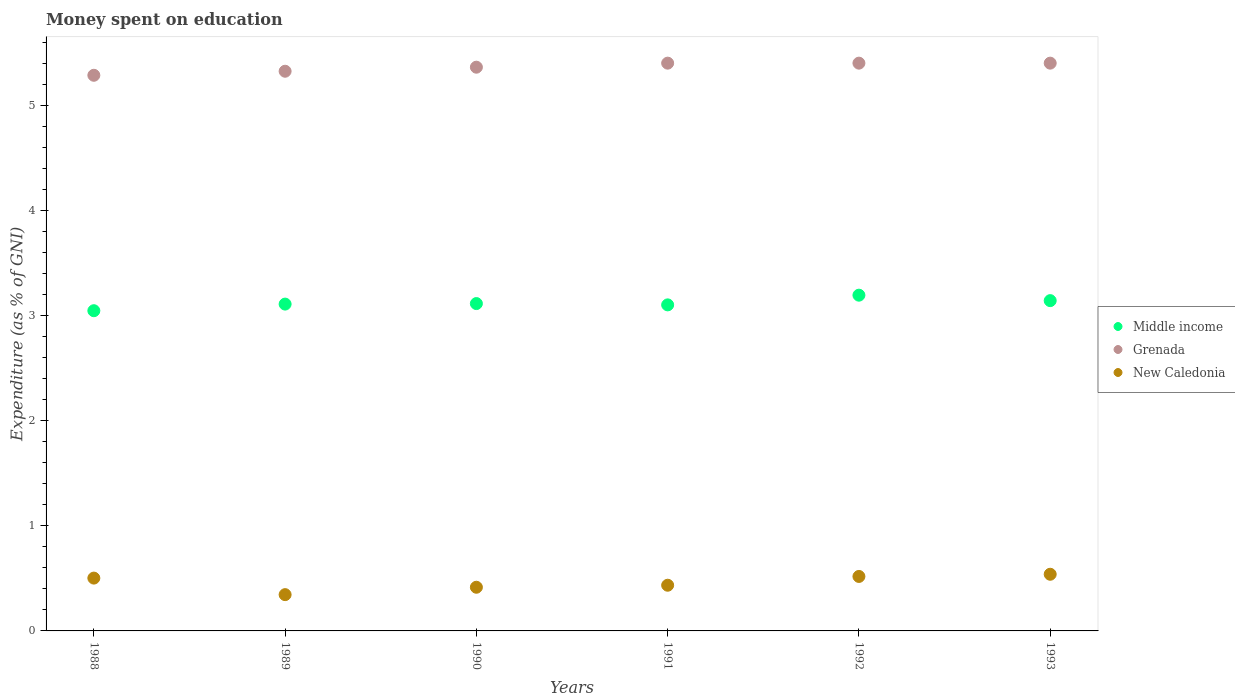How many different coloured dotlines are there?
Ensure brevity in your answer.  3. Is the number of dotlines equal to the number of legend labels?
Provide a succinct answer. Yes. What is the amount of money spent on education in Middle income in 1993?
Give a very brief answer. 3.14. Across all years, what is the maximum amount of money spent on education in New Caledonia?
Ensure brevity in your answer.  0.54. Across all years, what is the minimum amount of money spent on education in Grenada?
Your response must be concise. 5.28. What is the total amount of money spent on education in Grenada in the graph?
Offer a terse response. 32.17. What is the difference between the amount of money spent on education in New Caledonia in 1990 and that in 1992?
Your answer should be compact. -0.1. What is the difference between the amount of money spent on education in New Caledonia in 1993 and the amount of money spent on education in Grenada in 1988?
Offer a very short reply. -4.75. What is the average amount of money spent on education in Grenada per year?
Your answer should be very brief. 5.36. In the year 1990, what is the difference between the amount of money spent on education in New Caledonia and amount of money spent on education in Grenada?
Provide a succinct answer. -4.95. What is the ratio of the amount of money spent on education in Grenada in 1988 to that in 1991?
Your answer should be compact. 0.98. Is the difference between the amount of money spent on education in New Caledonia in 1988 and 1990 greater than the difference between the amount of money spent on education in Grenada in 1988 and 1990?
Your response must be concise. Yes. What is the difference between the highest and the second highest amount of money spent on education in New Caledonia?
Offer a very short reply. 0.02. What is the difference between the highest and the lowest amount of money spent on education in Middle income?
Provide a succinct answer. 0.15. In how many years, is the amount of money spent on education in New Caledonia greater than the average amount of money spent on education in New Caledonia taken over all years?
Offer a terse response. 3. Is the sum of the amount of money spent on education in Middle income in 1988 and 1991 greater than the maximum amount of money spent on education in New Caledonia across all years?
Offer a terse response. Yes. Is it the case that in every year, the sum of the amount of money spent on education in Middle income and amount of money spent on education in New Caledonia  is greater than the amount of money spent on education in Grenada?
Provide a short and direct response. No. Is the amount of money spent on education in Grenada strictly less than the amount of money spent on education in New Caledonia over the years?
Make the answer very short. No. How many years are there in the graph?
Provide a short and direct response. 6. What is the difference between two consecutive major ticks on the Y-axis?
Your response must be concise. 1. Does the graph contain any zero values?
Provide a succinct answer. No. How are the legend labels stacked?
Your response must be concise. Vertical. What is the title of the graph?
Offer a terse response. Money spent on education. Does "Turkey" appear as one of the legend labels in the graph?
Provide a succinct answer. No. What is the label or title of the Y-axis?
Offer a terse response. Expenditure (as % of GNI). What is the Expenditure (as % of GNI) in Middle income in 1988?
Keep it short and to the point. 3.05. What is the Expenditure (as % of GNI) in Grenada in 1988?
Provide a short and direct response. 5.28. What is the Expenditure (as % of GNI) of New Caledonia in 1988?
Offer a terse response. 0.5. What is the Expenditure (as % of GNI) in Middle income in 1989?
Your answer should be compact. 3.11. What is the Expenditure (as % of GNI) of Grenada in 1989?
Ensure brevity in your answer.  5.32. What is the Expenditure (as % of GNI) of New Caledonia in 1989?
Your answer should be compact. 0.35. What is the Expenditure (as % of GNI) in Middle income in 1990?
Your answer should be very brief. 3.11. What is the Expenditure (as % of GNI) in Grenada in 1990?
Give a very brief answer. 5.36. What is the Expenditure (as % of GNI) in New Caledonia in 1990?
Give a very brief answer. 0.42. What is the Expenditure (as % of GNI) of Middle income in 1991?
Offer a terse response. 3.1. What is the Expenditure (as % of GNI) of New Caledonia in 1991?
Provide a succinct answer. 0.43. What is the Expenditure (as % of GNI) in Middle income in 1992?
Your answer should be very brief. 3.19. What is the Expenditure (as % of GNI) in Grenada in 1992?
Offer a terse response. 5.4. What is the Expenditure (as % of GNI) of New Caledonia in 1992?
Provide a short and direct response. 0.52. What is the Expenditure (as % of GNI) of Middle income in 1993?
Offer a very short reply. 3.14. What is the Expenditure (as % of GNI) of Grenada in 1993?
Offer a terse response. 5.4. What is the Expenditure (as % of GNI) of New Caledonia in 1993?
Make the answer very short. 0.54. Across all years, what is the maximum Expenditure (as % of GNI) in Middle income?
Give a very brief answer. 3.19. Across all years, what is the maximum Expenditure (as % of GNI) of New Caledonia?
Your answer should be very brief. 0.54. Across all years, what is the minimum Expenditure (as % of GNI) in Middle income?
Offer a very short reply. 3.05. Across all years, what is the minimum Expenditure (as % of GNI) of Grenada?
Offer a very short reply. 5.28. Across all years, what is the minimum Expenditure (as % of GNI) of New Caledonia?
Ensure brevity in your answer.  0.35. What is the total Expenditure (as % of GNI) of Middle income in the graph?
Offer a very short reply. 18.7. What is the total Expenditure (as % of GNI) in Grenada in the graph?
Ensure brevity in your answer.  32.17. What is the total Expenditure (as % of GNI) in New Caledonia in the graph?
Your answer should be very brief. 2.75. What is the difference between the Expenditure (as % of GNI) of Middle income in 1988 and that in 1989?
Make the answer very short. -0.06. What is the difference between the Expenditure (as % of GNI) in Grenada in 1988 and that in 1989?
Make the answer very short. -0.04. What is the difference between the Expenditure (as % of GNI) in New Caledonia in 1988 and that in 1989?
Offer a terse response. 0.16. What is the difference between the Expenditure (as % of GNI) in Middle income in 1988 and that in 1990?
Keep it short and to the point. -0.07. What is the difference between the Expenditure (as % of GNI) in Grenada in 1988 and that in 1990?
Your answer should be compact. -0.08. What is the difference between the Expenditure (as % of GNI) of New Caledonia in 1988 and that in 1990?
Offer a terse response. 0.09. What is the difference between the Expenditure (as % of GNI) in Middle income in 1988 and that in 1991?
Make the answer very short. -0.06. What is the difference between the Expenditure (as % of GNI) in Grenada in 1988 and that in 1991?
Provide a succinct answer. -0.12. What is the difference between the Expenditure (as % of GNI) of New Caledonia in 1988 and that in 1991?
Your answer should be very brief. 0.07. What is the difference between the Expenditure (as % of GNI) of Middle income in 1988 and that in 1992?
Your answer should be compact. -0.15. What is the difference between the Expenditure (as % of GNI) in Grenada in 1988 and that in 1992?
Your answer should be compact. -0.12. What is the difference between the Expenditure (as % of GNI) of New Caledonia in 1988 and that in 1992?
Your answer should be compact. -0.02. What is the difference between the Expenditure (as % of GNI) in Middle income in 1988 and that in 1993?
Provide a succinct answer. -0.1. What is the difference between the Expenditure (as % of GNI) of Grenada in 1988 and that in 1993?
Provide a succinct answer. -0.12. What is the difference between the Expenditure (as % of GNI) of New Caledonia in 1988 and that in 1993?
Provide a short and direct response. -0.04. What is the difference between the Expenditure (as % of GNI) in Middle income in 1989 and that in 1990?
Ensure brevity in your answer.  -0.01. What is the difference between the Expenditure (as % of GNI) of Grenada in 1989 and that in 1990?
Provide a succinct answer. -0.04. What is the difference between the Expenditure (as % of GNI) in New Caledonia in 1989 and that in 1990?
Make the answer very short. -0.07. What is the difference between the Expenditure (as % of GNI) of Middle income in 1989 and that in 1991?
Provide a short and direct response. 0.01. What is the difference between the Expenditure (as % of GNI) in Grenada in 1989 and that in 1991?
Offer a very short reply. -0.08. What is the difference between the Expenditure (as % of GNI) of New Caledonia in 1989 and that in 1991?
Make the answer very short. -0.09. What is the difference between the Expenditure (as % of GNI) in Middle income in 1989 and that in 1992?
Offer a terse response. -0.08. What is the difference between the Expenditure (as % of GNI) in Grenada in 1989 and that in 1992?
Your answer should be very brief. -0.08. What is the difference between the Expenditure (as % of GNI) of New Caledonia in 1989 and that in 1992?
Keep it short and to the point. -0.17. What is the difference between the Expenditure (as % of GNI) in Middle income in 1989 and that in 1993?
Make the answer very short. -0.03. What is the difference between the Expenditure (as % of GNI) in Grenada in 1989 and that in 1993?
Provide a short and direct response. -0.08. What is the difference between the Expenditure (as % of GNI) of New Caledonia in 1989 and that in 1993?
Ensure brevity in your answer.  -0.19. What is the difference between the Expenditure (as % of GNI) of Middle income in 1990 and that in 1991?
Make the answer very short. 0.01. What is the difference between the Expenditure (as % of GNI) of Grenada in 1990 and that in 1991?
Provide a succinct answer. -0.04. What is the difference between the Expenditure (as % of GNI) in New Caledonia in 1990 and that in 1991?
Your answer should be very brief. -0.02. What is the difference between the Expenditure (as % of GNI) in Middle income in 1990 and that in 1992?
Ensure brevity in your answer.  -0.08. What is the difference between the Expenditure (as % of GNI) of Grenada in 1990 and that in 1992?
Offer a very short reply. -0.04. What is the difference between the Expenditure (as % of GNI) in New Caledonia in 1990 and that in 1992?
Ensure brevity in your answer.  -0.1. What is the difference between the Expenditure (as % of GNI) in Middle income in 1990 and that in 1993?
Offer a very short reply. -0.03. What is the difference between the Expenditure (as % of GNI) in Grenada in 1990 and that in 1993?
Give a very brief answer. -0.04. What is the difference between the Expenditure (as % of GNI) in New Caledonia in 1990 and that in 1993?
Your answer should be compact. -0.12. What is the difference between the Expenditure (as % of GNI) of Middle income in 1991 and that in 1992?
Provide a succinct answer. -0.09. What is the difference between the Expenditure (as % of GNI) in Grenada in 1991 and that in 1992?
Offer a very short reply. 0. What is the difference between the Expenditure (as % of GNI) in New Caledonia in 1991 and that in 1992?
Your answer should be compact. -0.08. What is the difference between the Expenditure (as % of GNI) in Middle income in 1991 and that in 1993?
Provide a short and direct response. -0.04. What is the difference between the Expenditure (as % of GNI) in Grenada in 1991 and that in 1993?
Make the answer very short. 0. What is the difference between the Expenditure (as % of GNI) in New Caledonia in 1991 and that in 1993?
Offer a terse response. -0.1. What is the difference between the Expenditure (as % of GNI) of Middle income in 1992 and that in 1993?
Your answer should be very brief. 0.05. What is the difference between the Expenditure (as % of GNI) of Grenada in 1992 and that in 1993?
Ensure brevity in your answer.  0. What is the difference between the Expenditure (as % of GNI) in New Caledonia in 1992 and that in 1993?
Offer a very short reply. -0.02. What is the difference between the Expenditure (as % of GNI) in Middle income in 1988 and the Expenditure (as % of GNI) in Grenada in 1989?
Keep it short and to the point. -2.28. What is the difference between the Expenditure (as % of GNI) in Middle income in 1988 and the Expenditure (as % of GNI) in New Caledonia in 1989?
Ensure brevity in your answer.  2.7. What is the difference between the Expenditure (as % of GNI) of Grenada in 1988 and the Expenditure (as % of GNI) of New Caledonia in 1989?
Your response must be concise. 4.94. What is the difference between the Expenditure (as % of GNI) of Middle income in 1988 and the Expenditure (as % of GNI) of Grenada in 1990?
Your response must be concise. -2.32. What is the difference between the Expenditure (as % of GNI) of Middle income in 1988 and the Expenditure (as % of GNI) of New Caledonia in 1990?
Provide a short and direct response. 2.63. What is the difference between the Expenditure (as % of GNI) of Grenada in 1988 and the Expenditure (as % of GNI) of New Caledonia in 1990?
Offer a very short reply. 4.87. What is the difference between the Expenditure (as % of GNI) of Middle income in 1988 and the Expenditure (as % of GNI) of Grenada in 1991?
Your answer should be very brief. -2.35. What is the difference between the Expenditure (as % of GNI) in Middle income in 1988 and the Expenditure (as % of GNI) in New Caledonia in 1991?
Offer a very short reply. 2.61. What is the difference between the Expenditure (as % of GNI) of Grenada in 1988 and the Expenditure (as % of GNI) of New Caledonia in 1991?
Provide a short and direct response. 4.85. What is the difference between the Expenditure (as % of GNI) of Middle income in 1988 and the Expenditure (as % of GNI) of Grenada in 1992?
Keep it short and to the point. -2.35. What is the difference between the Expenditure (as % of GNI) in Middle income in 1988 and the Expenditure (as % of GNI) in New Caledonia in 1992?
Offer a terse response. 2.53. What is the difference between the Expenditure (as % of GNI) in Grenada in 1988 and the Expenditure (as % of GNI) in New Caledonia in 1992?
Your response must be concise. 4.77. What is the difference between the Expenditure (as % of GNI) in Middle income in 1988 and the Expenditure (as % of GNI) in Grenada in 1993?
Your response must be concise. -2.35. What is the difference between the Expenditure (as % of GNI) in Middle income in 1988 and the Expenditure (as % of GNI) in New Caledonia in 1993?
Ensure brevity in your answer.  2.51. What is the difference between the Expenditure (as % of GNI) in Grenada in 1988 and the Expenditure (as % of GNI) in New Caledonia in 1993?
Your answer should be very brief. 4.75. What is the difference between the Expenditure (as % of GNI) in Middle income in 1989 and the Expenditure (as % of GNI) in Grenada in 1990?
Give a very brief answer. -2.25. What is the difference between the Expenditure (as % of GNI) in Middle income in 1989 and the Expenditure (as % of GNI) in New Caledonia in 1990?
Offer a terse response. 2.69. What is the difference between the Expenditure (as % of GNI) of Grenada in 1989 and the Expenditure (as % of GNI) of New Caledonia in 1990?
Give a very brief answer. 4.91. What is the difference between the Expenditure (as % of GNI) of Middle income in 1989 and the Expenditure (as % of GNI) of Grenada in 1991?
Provide a succinct answer. -2.29. What is the difference between the Expenditure (as % of GNI) of Middle income in 1989 and the Expenditure (as % of GNI) of New Caledonia in 1991?
Offer a very short reply. 2.67. What is the difference between the Expenditure (as % of GNI) of Grenada in 1989 and the Expenditure (as % of GNI) of New Caledonia in 1991?
Ensure brevity in your answer.  4.89. What is the difference between the Expenditure (as % of GNI) in Middle income in 1989 and the Expenditure (as % of GNI) in Grenada in 1992?
Offer a very short reply. -2.29. What is the difference between the Expenditure (as % of GNI) in Middle income in 1989 and the Expenditure (as % of GNI) in New Caledonia in 1992?
Give a very brief answer. 2.59. What is the difference between the Expenditure (as % of GNI) of Grenada in 1989 and the Expenditure (as % of GNI) of New Caledonia in 1992?
Offer a terse response. 4.8. What is the difference between the Expenditure (as % of GNI) of Middle income in 1989 and the Expenditure (as % of GNI) of Grenada in 1993?
Your answer should be very brief. -2.29. What is the difference between the Expenditure (as % of GNI) in Middle income in 1989 and the Expenditure (as % of GNI) in New Caledonia in 1993?
Your answer should be very brief. 2.57. What is the difference between the Expenditure (as % of GNI) of Grenada in 1989 and the Expenditure (as % of GNI) of New Caledonia in 1993?
Provide a succinct answer. 4.78. What is the difference between the Expenditure (as % of GNI) in Middle income in 1990 and the Expenditure (as % of GNI) in Grenada in 1991?
Your response must be concise. -2.29. What is the difference between the Expenditure (as % of GNI) of Middle income in 1990 and the Expenditure (as % of GNI) of New Caledonia in 1991?
Provide a succinct answer. 2.68. What is the difference between the Expenditure (as % of GNI) of Grenada in 1990 and the Expenditure (as % of GNI) of New Caledonia in 1991?
Your response must be concise. 4.93. What is the difference between the Expenditure (as % of GNI) in Middle income in 1990 and the Expenditure (as % of GNI) in Grenada in 1992?
Provide a short and direct response. -2.29. What is the difference between the Expenditure (as % of GNI) of Middle income in 1990 and the Expenditure (as % of GNI) of New Caledonia in 1992?
Ensure brevity in your answer.  2.6. What is the difference between the Expenditure (as % of GNI) in Grenada in 1990 and the Expenditure (as % of GNI) in New Caledonia in 1992?
Give a very brief answer. 4.84. What is the difference between the Expenditure (as % of GNI) of Middle income in 1990 and the Expenditure (as % of GNI) of Grenada in 1993?
Offer a very short reply. -2.29. What is the difference between the Expenditure (as % of GNI) of Middle income in 1990 and the Expenditure (as % of GNI) of New Caledonia in 1993?
Your answer should be very brief. 2.57. What is the difference between the Expenditure (as % of GNI) in Grenada in 1990 and the Expenditure (as % of GNI) in New Caledonia in 1993?
Your answer should be compact. 4.82. What is the difference between the Expenditure (as % of GNI) of Middle income in 1991 and the Expenditure (as % of GNI) of Grenada in 1992?
Your answer should be compact. -2.3. What is the difference between the Expenditure (as % of GNI) of Middle income in 1991 and the Expenditure (as % of GNI) of New Caledonia in 1992?
Your answer should be very brief. 2.58. What is the difference between the Expenditure (as % of GNI) in Grenada in 1991 and the Expenditure (as % of GNI) in New Caledonia in 1992?
Offer a very short reply. 4.88. What is the difference between the Expenditure (as % of GNI) in Middle income in 1991 and the Expenditure (as % of GNI) in Grenada in 1993?
Ensure brevity in your answer.  -2.3. What is the difference between the Expenditure (as % of GNI) of Middle income in 1991 and the Expenditure (as % of GNI) of New Caledonia in 1993?
Your response must be concise. 2.56. What is the difference between the Expenditure (as % of GNI) of Grenada in 1991 and the Expenditure (as % of GNI) of New Caledonia in 1993?
Your answer should be very brief. 4.86. What is the difference between the Expenditure (as % of GNI) in Middle income in 1992 and the Expenditure (as % of GNI) in Grenada in 1993?
Keep it short and to the point. -2.21. What is the difference between the Expenditure (as % of GNI) of Middle income in 1992 and the Expenditure (as % of GNI) of New Caledonia in 1993?
Keep it short and to the point. 2.65. What is the difference between the Expenditure (as % of GNI) of Grenada in 1992 and the Expenditure (as % of GNI) of New Caledonia in 1993?
Give a very brief answer. 4.86. What is the average Expenditure (as % of GNI) of Middle income per year?
Offer a very short reply. 3.12. What is the average Expenditure (as % of GNI) in Grenada per year?
Provide a short and direct response. 5.36. What is the average Expenditure (as % of GNI) of New Caledonia per year?
Offer a very short reply. 0.46. In the year 1988, what is the difference between the Expenditure (as % of GNI) of Middle income and Expenditure (as % of GNI) of Grenada?
Offer a terse response. -2.24. In the year 1988, what is the difference between the Expenditure (as % of GNI) of Middle income and Expenditure (as % of GNI) of New Caledonia?
Make the answer very short. 2.54. In the year 1988, what is the difference between the Expenditure (as % of GNI) of Grenada and Expenditure (as % of GNI) of New Caledonia?
Keep it short and to the point. 4.78. In the year 1989, what is the difference between the Expenditure (as % of GNI) of Middle income and Expenditure (as % of GNI) of Grenada?
Your response must be concise. -2.21. In the year 1989, what is the difference between the Expenditure (as % of GNI) of Middle income and Expenditure (as % of GNI) of New Caledonia?
Give a very brief answer. 2.76. In the year 1989, what is the difference between the Expenditure (as % of GNI) in Grenada and Expenditure (as % of GNI) in New Caledonia?
Your answer should be very brief. 4.98. In the year 1990, what is the difference between the Expenditure (as % of GNI) of Middle income and Expenditure (as % of GNI) of Grenada?
Offer a very short reply. -2.25. In the year 1990, what is the difference between the Expenditure (as % of GNI) of Middle income and Expenditure (as % of GNI) of New Caledonia?
Provide a short and direct response. 2.7. In the year 1990, what is the difference between the Expenditure (as % of GNI) of Grenada and Expenditure (as % of GNI) of New Caledonia?
Provide a short and direct response. 4.95. In the year 1991, what is the difference between the Expenditure (as % of GNI) of Middle income and Expenditure (as % of GNI) of Grenada?
Give a very brief answer. -2.3. In the year 1991, what is the difference between the Expenditure (as % of GNI) in Middle income and Expenditure (as % of GNI) in New Caledonia?
Give a very brief answer. 2.67. In the year 1991, what is the difference between the Expenditure (as % of GNI) in Grenada and Expenditure (as % of GNI) in New Caledonia?
Offer a very short reply. 4.97. In the year 1992, what is the difference between the Expenditure (as % of GNI) in Middle income and Expenditure (as % of GNI) in Grenada?
Keep it short and to the point. -2.21. In the year 1992, what is the difference between the Expenditure (as % of GNI) of Middle income and Expenditure (as % of GNI) of New Caledonia?
Ensure brevity in your answer.  2.68. In the year 1992, what is the difference between the Expenditure (as % of GNI) of Grenada and Expenditure (as % of GNI) of New Caledonia?
Keep it short and to the point. 4.88. In the year 1993, what is the difference between the Expenditure (as % of GNI) of Middle income and Expenditure (as % of GNI) of Grenada?
Ensure brevity in your answer.  -2.26. In the year 1993, what is the difference between the Expenditure (as % of GNI) of Middle income and Expenditure (as % of GNI) of New Caledonia?
Make the answer very short. 2.6. In the year 1993, what is the difference between the Expenditure (as % of GNI) in Grenada and Expenditure (as % of GNI) in New Caledonia?
Provide a short and direct response. 4.86. What is the ratio of the Expenditure (as % of GNI) in Middle income in 1988 to that in 1989?
Give a very brief answer. 0.98. What is the ratio of the Expenditure (as % of GNI) in Grenada in 1988 to that in 1989?
Offer a terse response. 0.99. What is the ratio of the Expenditure (as % of GNI) in New Caledonia in 1988 to that in 1989?
Provide a short and direct response. 1.46. What is the ratio of the Expenditure (as % of GNI) in Middle income in 1988 to that in 1990?
Your answer should be compact. 0.98. What is the ratio of the Expenditure (as % of GNI) of Grenada in 1988 to that in 1990?
Offer a terse response. 0.99. What is the ratio of the Expenditure (as % of GNI) in New Caledonia in 1988 to that in 1990?
Provide a short and direct response. 1.21. What is the ratio of the Expenditure (as % of GNI) in Middle income in 1988 to that in 1991?
Keep it short and to the point. 0.98. What is the ratio of the Expenditure (as % of GNI) in Grenada in 1988 to that in 1991?
Offer a very short reply. 0.98. What is the ratio of the Expenditure (as % of GNI) of New Caledonia in 1988 to that in 1991?
Your response must be concise. 1.16. What is the ratio of the Expenditure (as % of GNI) in Middle income in 1988 to that in 1992?
Make the answer very short. 0.95. What is the ratio of the Expenditure (as % of GNI) of Grenada in 1988 to that in 1992?
Offer a very short reply. 0.98. What is the ratio of the Expenditure (as % of GNI) in New Caledonia in 1988 to that in 1992?
Your answer should be very brief. 0.97. What is the ratio of the Expenditure (as % of GNI) of Middle income in 1988 to that in 1993?
Ensure brevity in your answer.  0.97. What is the ratio of the Expenditure (as % of GNI) of Grenada in 1988 to that in 1993?
Make the answer very short. 0.98. What is the ratio of the Expenditure (as % of GNI) in New Caledonia in 1988 to that in 1993?
Make the answer very short. 0.93. What is the ratio of the Expenditure (as % of GNI) in New Caledonia in 1989 to that in 1990?
Offer a terse response. 0.83. What is the ratio of the Expenditure (as % of GNI) of Middle income in 1989 to that in 1991?
Provide a succinct answer. 1. What is the ratio of the Expenditure (as % of GNI) in Grenada in 1989 to that in 1991?
Your response must be concise. 0.99. What is the ratio of the Expenditure (as % of GNI) in New Caledonia in 1989 to that in 1991?
Provide a succinct answer. 0.79. What is the ratio of the Expenditure (as % of GNI) of Middle income in 1989 to that in 1992?
Keep it short and to the point. 0.97. What is the ratio of the Expenditure (as % of GNI) in Grenada in 1989 to that in 1992?
Ensure brevity in your answer.  0.99. What is the ratio of the Expenditure (as % of GNI) of New Caledonia in 1989 to that in 1992?
Give a very brief answer. 0.67. What is the ratio of the Expenditure (as % of GNI) of Middle income in 1989 to that in 1993?
Your answer should be very brief. 0.99. What is the ratio of the Expenditure (as % of GNI) in Grenada in 1989 to that in 1993?
Ensure brevity in your answer.  0.99. What is the ratio of the Expenditure (as % of GNI) in New Caledonia in 1989 to that in 1993?
Ensure brevity in your answer.  0.64. What is the ratio of the Expenditure (as % of GNI) in Middle income in 1990 to that in 1991?
Keep it short and to the point. 1. What is the ratio of the Expenditure (as % of GNI) in New Caledonia in 1990 to that in 1991?
Provide a short and direct response. 0.96. What is the ratio of the Expenditure (as % of GNI) in Grenada in 1990 to that in 1992?
Make the answer very short. 0.99. What is the ratio of the Expenditure (as % of GNI) in New Caledonia in 1990 to that in 1992?
Offer a very short reply. 0.8. What is the ratio of the Expenditure (as % of GNI) of Middle income in 1990 to that in 1993?
Your answer should be very brief. 0.99. What is the ratio of the Expenditure (as % of GNI) of New Caledonia in 1990 to that in 1993?
Give a very brief answer. 0.77. What is the ratio of the Expenditure (as % of GNI) in Middle income in 1991 to that in 1992?
Provide a short and direct response. 0.97. What is the ratio of the Expenditure (as % of GNI) in New Caledonia in 1991 to that in 1992?
Offer a very short reply. 0.84. What is the ratio of the Expenditure (as % of GNI) in Middle income in 1991 to that in 1993?
Ensure brevity in your answer.  0.99. What is the ratio of the Expenditure (as % of GNI) in New Caledonia in 1991 to that in 1993?
Your answer should be very brief. 0.81. What is the ratio of the Expenditure (as % of GNI) of Middle income in 1992 to that in 1993?
Give a very brief answer. 1.02. What is the ratio of the Expenditure (as % of GNI) of Grenada in 1992 to that in 1993?
Your answer should be very brief. 1. What is the ratio of the Expenditure (as % of GNI) of New Caledonia in 1992 to that in 1993?
Give a very brief answer. 0.96. What is the difference between the highest and the second highest Expenditure (as % of GNI) of Middle income?
Provide a succinct answer. 0.05. What is the difference between the highest and the second highest Expenditure (as % of GNI) in New Caledonia?
Provide a succinct answer. 0.02. What is the difference between the highest and the lowest Expenditure (as % of GNI) in Middle income?
Ensure brevity in your answer.  0.15. What is the difference between the highest and the lowest Expenditure (as % of GNI) in Grenada?
Ensure brevity in your answer.  0.12. What is the difference between the highest and the lowest Expenditure (as % of GNI) in New Caledonia?
Your answer should be very brief. 0.19. 